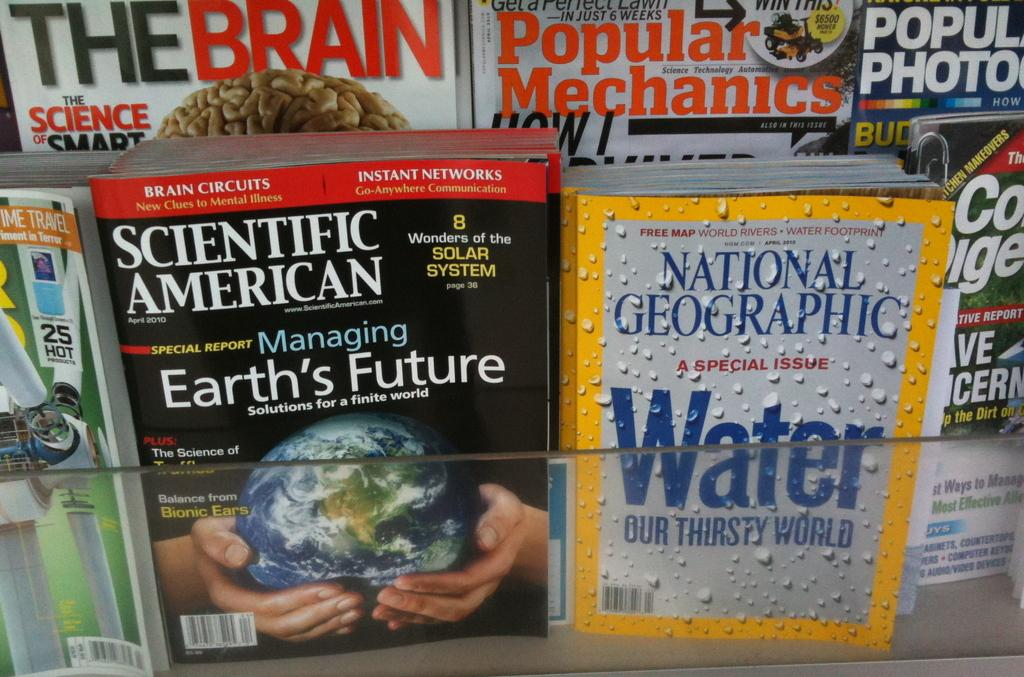<image>
Offer a succinct explanation of the picture presented. National Geographic special issue about Water is on a newsstand display along with several other magazines. 